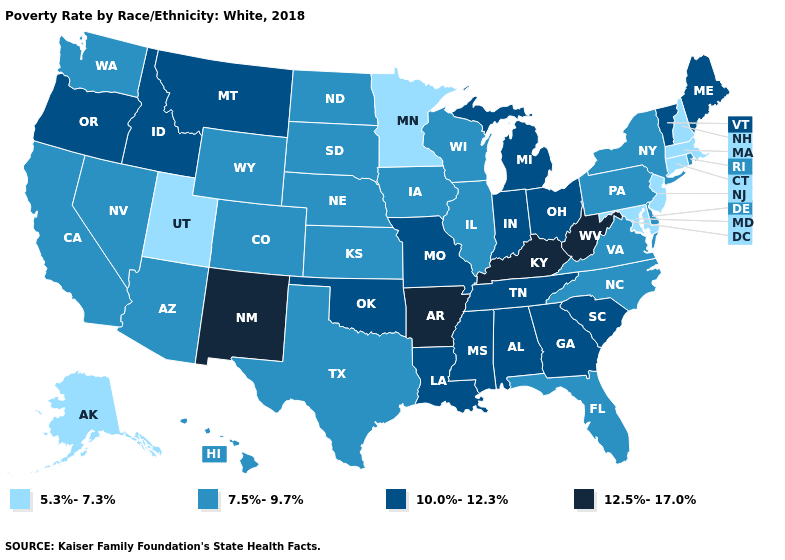What is the highest value in the Northeast ?
Short answer required. 10.0%-12.3%. What is the highest value in states that border Texas?
Short answer required. 12.5%-17.0%. Which states have the highest value in the USA?
Concise answer only. Arkansas, Kentucky, New Mexico, West Virginia. Which states have the highest value in the USA?
Be succinct. Arkansas, Kentucky, New Mexico, West Virginia. What is the value of Arkansas?
Answer briefly. 12.5%-17.0%. Does Georgia have the highest value in the South?
Give a very brief answer. No. Among the states that border New Mexico , does Colorado have the lowest value?
Write a very short answer. No. What is the lowest value in states that border Rhode Island?
Concise answer only. 5.3%-7.3%. Among the states that border Michigan , does Indiana have the highest value?
Write a very short answer. Yes. Name the states that have a value in the range 5.3%-7.3%?
Quick response, please. Alaska, Connecticut, Maryland, Massachusetts, Minnesota, New Hampshire, New Jersey, Utah. What is the lowest value in the West?
Keep it brief. 5.3%-7.3%. Name the states that have a value in the range 12.5%-17.0%?
Answer briefly. Arkansas, Kentucky, New Mexico, West Virginia. Name the states that have a value in the range 5.3%-7.3%?
Be succinct. Alaska, Connecticut, Maryland, Massachusetts, Minnesota, New Hampshire, New Jersey, Utah. Name the states that have a value in the range 10.0%-12.3%?
Keep it brief. Alabama, Georgia, Idaho, Indiana, Louisiana, Maine, Michigan, Mississippi, Missouri, Montana, Ohio, Oklahoma, Oregon, South Carolina, Tennessee, Vermont. Name the states that have a value in the range 7.5%-9.7%?
Write a very short answer. Arizona, California, Colorado, Delaware, Florida, Hawaii, Illinois, Iowa, Kansas, Nebraska, Nevada, New York, North Carolina, North Dakota, Pennsylvania, Rhode Island, South Dakota, Texas, Virginia, Washington, Wisconsin, Wyoming. 